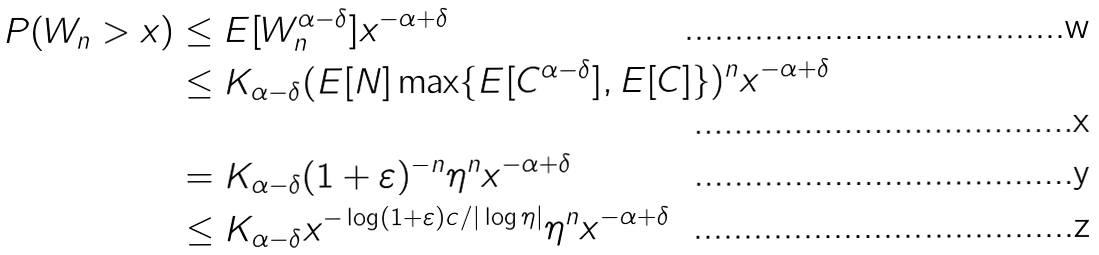<formula> <loc_0><loc_0><loc_500><loc_500>P ( W _ { n } > x ) & \leq E [ W _ { n } ^ { \alpha - \delta } ] x ^ { - \alpha + \delta } \\ & \leq K _ { \alpha - \delta } ( E [ N ] \max \{ E [ C ^ { \alpha - \delta } ] , E [ C ] \} ) ^ { n } x ^ { - \alpha + \delta } \\ & = K _ { \alpha - \delta } ( 1 + \varepsilon ) ^ { - n } \eta ^ { n } x ^ { - \alpha + \delta } \\ & \leq K _ { \alpha - \delta } x ^ { - \log ( 1 + \varepsilon ) c / | \log \eta | } \eta ^ { n } x ^ { - \alpha + \delta }</formula> 